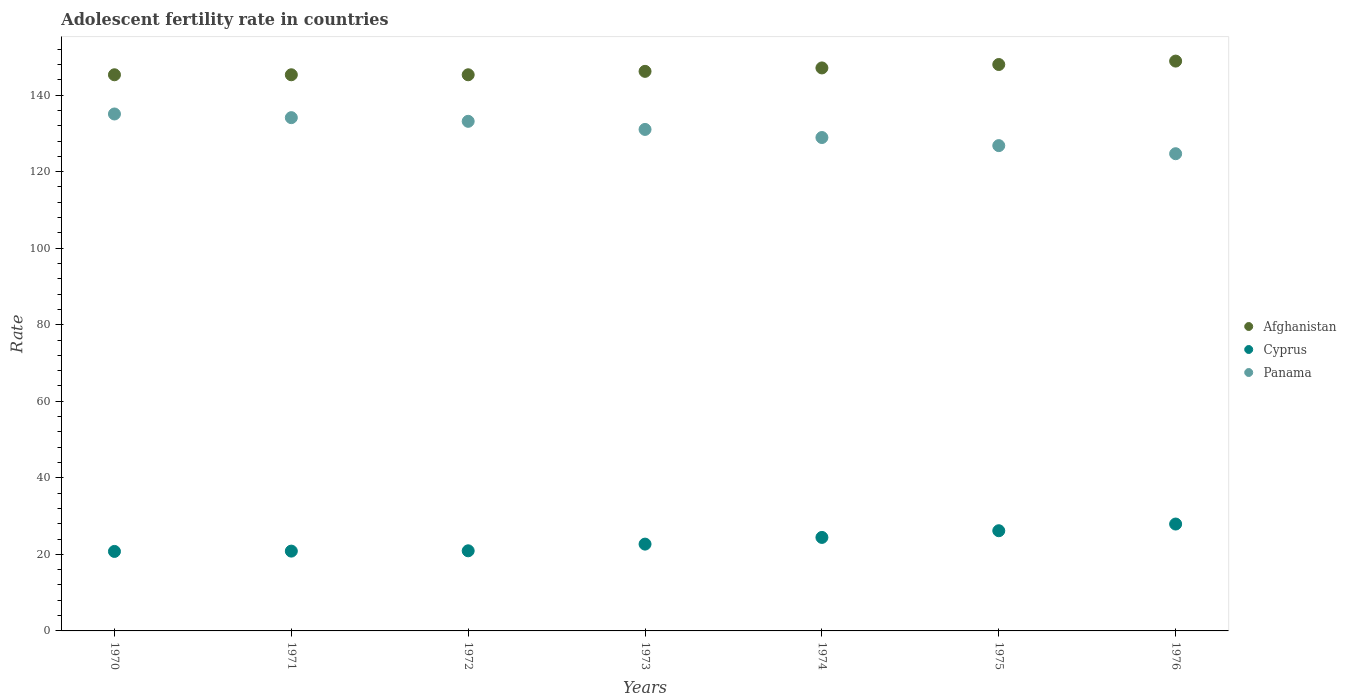How many different coloured dotlines are there?
Provide a succinct answer. 3. Is the number of dotlines equal to the number of legend labels?
Give a very brief answer. Yes. What is the adolescent fertility rate in Afghanistan in 1973?
Your response must be concise. 146.22. Across all years, what is the maximum adolescent fertility rate in Afghanistan?
Ensure brevity in your answer.  148.9. Across all years, what is the minimum adolescent fertility rate in Afghanistan?
Offer a very short reply. 145.32. In which year was the adolescent fertility rate in Panama maximum?
Offer a very short reply. 1970. What is the total adolescent fertility rate in Panama in the graph?
Your answer should be compact. 913.82. What is the difference between the adolescent fertility rate in Afghanistan in 1970 and that in 1975?
Ensure brevity in your answer.  -2.68. What is the difference between the adolescent fertility rate in Panama in 1975 and the adolescent fertility rate in Afghanistan in 1974?
Ensure brevity in your answer.  -20.3. What is the average adolescent fertility rate in Cyprus per year?
Give a very brief answer. 23.4. In the year 1972, what is the difference between the adolescent fertility rate in Cyprus and adolescent fertility rate in Afghanistan?
Offer a terse response. -124.38. What is the ratio of the adolescent fertility rate in Cyprus in 1972 to that in 1976?
Offer a very short reply. 0.75. Is the adolescent fertility rate in Panama in 1974 less than that in 1976?
Provide a short and direct response. No. Is the difference between the adolescent fertility rate in Cyprus in 1970 and 1974 greater than the difference between the adolescent fertility rate in Afghanistan in 1970 and 1974?
Your answer should be very brief. No. What is the difference between the highest and the second highest adolescent fertility rate in Panama?
Give a very brief answer. 0.96. What is the difference between the highest and the lowest adolescent fertility rate in Afghanistan?
Offer a terse response. 3.58. Is the adolescent fertility rate in Panama strictly greater than the adolescent fertility rate in Afghanistan over the years?
Your answer should be very brief. No. Is the adolescent fertility rate in Cyprus strictly less than the adolescent fertility rate in Afghanistan over the years?
Your answer should be very brief. Yes. How many years are there in the graph?
Provide a short and direct response. 7. What is the difference between two consecutive major ticks on the Y-axis?
Ensure brevity in your answer.  20. Does the graph contain any zero values?
Provide a short and direct response. No. Does the graph contain grids?
Provide a succinct answer. No. Where does the legend appear in the graph?
Offer a terse response. Center right. How many legend labels are there?
Give a very brief answer. 3. What is the title of the graph?
Offer a very short reply. Adolescent fertility rate in countries. Does "Botswana" appear as one of the legend labels in the graph?
Ensure brevity in your answer.  No. What is the label or title of the Y-axis?
Your answer should be very brief. Rate. What is the Rate in Afghanistan in 1970?
Give a very brief answer. 145.32. What is the Rate of Cyprus in 1970?
Keep it short and to the point. 20.77. What is the Rate in Panama in 1970?
Give a very brief answer. 135.08. What is the Rate of Afghanistan in 1971?
Offer a terse response. 145.32. What is the Rate in Cyprus in 1971?
Your answer should be compact. 20.85. What is the Rate in Panama in 1971?
Offer a very short reply. 134.12. What is the Rate of Afghanistan in 1972?
Ensure brevity in your answer.  145.32. What is the Rate in Cyprus in 1972?
Provide a short and direct response. 20.94. What is the Rate in Panama in 1972?
Provide a short and direct response. 133.16. What is the Rate in Afghanistan in 1973?
Your answer should be compact. 146.22. What is the Rate in Cyprus in 1973?
Offer a very short reply. 22.68. What is the Rate in Panama in 1973?
Ensure brevity in your answer.  131.04. What is the Rate in Afghanistan in 1974?
Give a very brief answer. 147.11. What is the Rate in Cyprus in 1974?
Ensure brevity in your answer.  24.43. What is the Rate in Panama in 1974?
Give a very brief answer. 128.93. What is the Rate in Afghanistan in 1975?
Your answer should be very brief. 148. What is the Rate of Cyprus in 1975?
Give a very brief answer. 26.18. What is the Rate in Panama in 1975?
Ensure brevity in your answer.  126.81. What is the Rate of Afghanistan in 1976?
Offer a terse response. 148.9. What is the Rate in Cyprus in 1976?
Make the answer very short. 27.93. What is the Rate of Panama in 1976?
Keep it short and to the point. 124.69. Across all years, what is the maximum Rate in Afghanistan?
Your answer should be compact. 148.9. Across all years, what is the maximum Rate in Cyprus?
Provide a short and direct response. 27.93. Across all years, what is the maximum Rate in Panama?
Your answer should be compact. 135.08. Across all years, what is the minimum Rate in Afghanistan?
Ensure brevity in your answer.  145.32. Across all years, what is the minimum Rate of Cyprus?
Your answer should be compact. 20.77. Across all years, what is the minimum Rate in Panama?
Make the answer very short. 124.69. What is the total Rate in Afghanistan in the graph?
Offer a very short reply. 1026.19. What is the total Rate in Cyprus in the graph?
Offer a very short reply. 163.79. What is the total Rate of Panama in the graph?
Give a very brief answer. 913.82. What is the difference between the Rate in Cyprus in 1970 and that in 1971?
Provide a succinct answer. -0.08. What is the difference between the Rate in Panama in 1970 and that in 1971?
Provide a short and direct response. 0.96. What is the difference between the Rate in Afghanistan in 1970 and that in 1972?
Your answer should be compact. 0. What is the difference between the Rate of Cyprus in 1970 and that in 1972?
Provide a succinct answer. -0.16. What is the difference between the Rate in Panama in 1970 and that in 1972?
Give a very brief answer. 1.92. What is the difference between the Rate of Afghanistan in 1970 and that in 1973?
Keep it short and to the point. -0.89. What is the difference between the Rate of Cyprus in 1970 and that in 1973?
Offer a very short reply. -1.91. What is the difference between the Rate in Panama in 1970 and that in 1973?
Your answer should be compact. 4.03. What is the difference between the Rate of Afghanistan in 1970 and that in 1974?
Your answer should be compact. -1.79. What is the difference between the Rate in Cyprus in 1970 and that in 1974?
Ensure brevity in your answer.  -3.66. What is the difference between the Rate of Panama in 1970 and that in 1974?
Ensure brevity in your answer.  6.15. What is the difference between the Rate of Afghanistan in 1970 and that in 1975?
Provide a succinct answer. -2.68. What is the difference between the Rate of Cyprus in 1970 and that in 1975?
Ensure brevity in your answer.  -5.41. What is the difference between the Rate of Panama in 1970 and that in 1975?
Provide a short and direct response. 8.27. What is the difference between the Rate in Afghanistan in 1970 and that in 1976?
Make the answer very short. -3.58. What is the difference between the Rate in Cyprus in 1970 and that in 1976?
Your answer should be very brief. -7.16. What is the difference between the Rate in Panama in 1970 and that in 1976?
Offer a terse response. 10.38. What is the difference between the Rate in Cyprus in 1971 and that in 1972?
Offer a terse response. -0.08. What is the difference between the Rate in Panama in 1971 and that in 1972?
Your response must be concise. 0.96. What is the difference between the Rate of Afghanistan in 1971 and that in 1973?
Keep it short and to the point. -0.89. What is the difference between the Rate of Cyprus in 1971 and that in 1973?
Offer a very short reply. -1.83. What is the difference between the Rate in Panama in 1971 and that in 1973?
Your answer should be compact. 3.08. What is the difference between the Rate of Afghanistan in 1971 and that in 1974?
Offer a very short reply. -1.79. What is the difference between the Rate in Cyprus in 1971 and that in 1974?
Make the answer very short. -3.58. What is the difference between the Rate of Panama in 1971 and that in 1974?
Provide a short and direct response. 5.19. What is the difference between the Rate in Afghanistan in 1971 and that in 1975?
Offer a very short reply. -2.68. What is the difference between the Rate of Cyprus in 1971 and that in 1975?
Ensure brevity in your answer.  -5.33. What is the difference between the Rate in Panama in 1971 and that in 1975?
Your answer should be compact. 7.31. What is the difference between the Rate of Afghanistan in 1971 and that in 1976?
Keep it short and to the point. -3.58. What is the difference between the Rate of Cyprus in 1971 and that in 1976?
Your answer should be compact. -7.07. What is the difference between the Rate in Panama in 1971 and that in 1976?
Your answer should be very brief. 9.42. What is the difference between the Rate of Afghanistan in 1972 and that in 1973?
Give a very brief answer. -0.89. What is the difference between the Rate in Cyprus in 1972 and that in 1973?
Offer a terse response. -1.75. What is the difference between the Rate in Panama in 1972 and that in 1973?
Make the answer very short. 2.12. What is the difference between the Rate in Afghanistan in 1972 and that in 1974?
Your answer should be very brief. -1.79. What is the difference between the Rate of Cyprus in 1972 and that in 1974?
Offer a very short reply. -3.5. What is the difference between the Rate of Panama in 1972 and that in 1974?
Give a very brief answer. 4.23. What is the difference between the Rate of Afghanistan in 1972 and that in 1975?
Provide a short and direct response. -2.68. What is the difference between the Rate in Cyprus in 1972 and that in 1975?
Provide a short and direct response. -5.24. What is the difference between the Rate of Panama in 1972 and that in 1975?
Your answer should be very brief. 6.35. What is the difference between the Rate in Afghanistan in 1972 and that in 1976?
Give a very brief answer. -3.58. What is the difference between the Rate of Cyprus in 1972 and that in 1976?
Your response must be concise. -6.99. What is the difference between the Rate in Panama in 1972 and that in 1976?
Ensure brevity in your answer.  8.46. What is the difference between the Rate of Afghanistan in 1973 and that in 1974?
Your answer should be compact. -0.89. What is the difference between the Rate in Cyprus in 1973 and that in 1974?
Your response must be concise. -1.75. What is the difference between the Rate of Panama in 1973 and that in 1974?
Your answer should be compact. 2.12. What is the difference between the Rate in Afghanistan in 1973 and that in 1975?
Give a very brief answer. -1.79. What is the difference between the Rate of Cyprus in 1973 and that in 1975?
Provide a short and direct response. -3.5. What is the difference between the Rate of Panama in 1973 and that in 1975?
Make the answer very short. 4.23. What is the difference between the Rate in Afghanistan in 1973 and that in 1976?
Give a very brief answer. -2.68. What is the difference between the Rate in Cyprus in 1973 and that in 1976?
Offer a very short reply. -5.24. What is the difference between the Rate in Panama in 1973 and that in 1976?
Provide a succinct answer. 6.35. What is the difference between the Rate in Afghanistan in 1974 and that in 1975?
Offer a very short reply. -0.89. What is the difference between the Rate in Cyprus in 1974 and that in 1975?
Your answer should be very brief. -1.75. What is the difference between the Rate in Panama in 1974 and that in 1975?
Provide a succinct answer. 2.12. What is the difference between the Rate in Afghanistan in 1974 and that in 1976?
Ensure brevity in your answer.  -1.79. What is the difference between the Rate of Cyprus in 1974 and that in 1976?
Your response must be concise. -3.5. What is the difference between the Rate in Panama in 1974 and that in 1976?
Make the answer very short. 4.23. What is the difference between the Rate in Afghanistan in 1975 and that in 1976?
Offer a very short reply. -0.89. What is the difference between the Rate of Cyprus in 1975 and that in 1976?
Ensure brevity in your answer.  -1.75. What is the difference between the Rate of Panama in 1975 and that in 1976?
Keep it short and to the point. 2.12. What is the difference between the Rate in Afghanistan in 1970 and the Rate in Cyprus in 1971?
Provide a succinct answer. 124.47. What is the difference between the Rate of Afghanistan in 1970 and the Rate of Panama in 1971?
Ensure brevity in your answer.  11.2. What is the difference between the Rate of Cyprus in 1970 and the Rate of Panama in 1971?
Offer a terse response. -113.35. What is the difference between the Rate of Afghanistan in 1970 and the Rate of Cyprus in 1972?
Keep it short and to the point. 124.39. What is the difference between the Rate in Afghanistan in 1970 and the Rate in Panama in 1972?
Keep it short and to the point. 12.16. What is the difference between the Rate of Cyprus in 1970 and the Rate of Panama in 1972?
Your answer should be very brief. -112.39. What is the difference between the Rate of Afghanistan in 1970 and the Rate of Cyprus in 1973?
Your answer should be compact. 122.64. What is the difference between the Rate of Afghanistan in 1970 and the Rate of Panama in 1973?
Offer a terse response. 14.28. What is the difference between the Rate of Cyprus in 1970 and the Rate of Panama in 1973?
Offer a very short reply. -110.27. What is the difference between the Rate in Afghanistan in 1970 and the Rate in Cyprus in 1974?
Provide a short and direct response. 120.89. What is the difference between the Rate of Afghanistan in 1970 and the Rate of Panama in 1974?
Provide a succinct answer. 16.4. What is the difference between the Rate in Cyprus in 1970 and the Rate in Panama in 1974?
Make the answer very short. -108.15. What is the difference between the Rate in Afghanistan in 1970 and the Rate in Cyprus in 1975?
Make the answer very short. 119.14. What is the difference between the Rate in Afghanistan in 1970 and the Rate in Panama in 1975?
Ensure brevity in your answer.  18.51. What is the difference between the Rate of Cyprus in 1970 and the Rate of Panama in 1975?
Give a very brief answer. -106.04. What is the difference between the Rate in Afghanistan in 1970 and the Rate in Cyprus in 1976?
Provide a short and direct response. 117.39. What is the difference between the Rate in Afghanistan in 1970 and the Rate in Panama in 1976?
Keep it short and to the point. 20.63. What is the difference between the Rate in Cyprus in 1970 and the Rate in Panama in 1976?
Your response must be concise. -103.92. What is the difference between the Rate of Afghanistan in 1971 and the Rate of Cyprus in 1972?
Your response must be concise. 124.39. What is the difference between the Rate in Afghanistan in 1971 and the Rate in Panama in 1972?
Keep it short and to the point. 12.16. What is the difference between the Rate of Cyprus in 1971 and the Rate of Panama in 1972?
Ensure brevity in your answer.  -112.3. What is the difference between the Rate of Afghanistan in 1971 and the Rate of Cyprus in 1973?
Your answer should be very brief. 122.64. What is the difference between the Rate in Afghanistan in 1971 and the Rate in Panama in 1973?
Offer a very short reply. 14.28. What is the difference between the Rate in Cyprus in 1971 and the Rate in Panama in 1973?
Give a very brief answer. -110.19. What is the difference between the Rate of Afghanistan in 1971 and the Rate of Cyprus in 1974?
Your answer should be very brief. 120.89. What is the difference between the Rate of Afghanistan in 1971 and the Rate of Panama in 1974?
Provide a succinct answer. 16.4. What is the difference between the Rate of Cyprus in 1971 and the Rate of Panama in 1974?
Give a very brief answer. -108.07. What is the difference between the Rate of Afghanistan in 1971 and the Rate of Cyprus in 1975?
Provide a short and direct response. 119.14. What is the difference between the Rate in Afghanistan in 1971 and the Rate in Panama in 1975?
Your response must be concise. 18.51. What is the difference between the Rate of Cyprus in 1971 and the Rate of Panama in 1975?
Your answer should be compact. -105.96. What is the difference between the Rate of Afghanistan in 1971 and the Rate of Cyprus in 1976?
Provide a succinct answer. 117.39. What is the difference between the Rate in Afghanistan in 1971 and the Rate in Panama in 1976?
Your answer should be compact. 20.63. What is the difference between the Rate in Cyprus in 1971 and the Rate in Panama in 1976?
Offer a very short reply. -103.84. What is the difference between the Rate in Afghanistan in 1972 and the Rate in Cyprus in 1973?
Make the answer very short. 122.64. What is the difference between the Rate in Afghanistan in 1972 and the Rate in Panama in 1973?
Make the answer very short. 14.28. What is the difference between the Rate in Cyprus in 1972 and the Rate in Panama in 1973?
Your answer should be compact. -110.11. What is the difference between the Rate in Afghanistan in 1972 and the Rate in Cyprus in 1974?
Offer a terse response. 120.89. What is the difference between the Rate in Afghanistan in 1972 and the Rate in Panama in 1974?
Offer a very short reply. 16.4. What is the difference between the Rate in Cyprus in 1972 and the Rate in Panama in 1974?
Offer a very short reply. -107.99. What is the difference between the Rate of Afghanistan in 1972 and the Rate of Cyprus in 1975?
Provide a succinct answer. 119.14. What is the difference between the Rate in Afghanistan in 1972 and the Rate in Panama in 1975?
Your answer should be compact. 18.51. What is the difference between the Rate in Cyprus in 1972 and the Rate in Panama in 1975?
Provide a succinct answer. -105.87. What is the difference between the Rate in Afghanistan in 1972 and the Rate in Cyprus in 1976?
Your answer should be very brief. 117.39. What is the difference between the Rate of Afghanistan in 1972 and the Rate of Panama in 1976?
Your response must be concise. 20.63. What is the difference between the Rate of Cyprus in 1972 and the Rate of Panama in 1976?
Keep it short and to the point. -103.76. What is the difference between the Rate in Afghanistan in 1973 and the Rate in Cyprus in 1974?
Your response must be concise. 121.78. What is the difference between the Rate of Afghanistan in 1973 and the Rate of Panama in 1974?
Ensure brevity in your answer.  17.29. What is the difference between the Rate in Cyprus in 1973 and the Rate in Panama in 1974?
Make the answer very short. -106.24. What is the difference between the Rate in Afghanistan in 1973 and the Rate in Cyprus in 1975?
Give a very brief answer. 120.03. What is the difference between the Rate of Afghanistan in 1973 and the Rate of Panama in 1975?
Offer a very short reply. 19.41. What is the difference between the Rate in Cyprus in 1973 and the Rate in Panama in 1975?
Give a very brief answer. -104.13. What is the difference between the Rate of Afghanistan in 1973 and the Rate of Cyprus in 1976?
Make the answer very short. 118.29. What is the difference between the Rate of Afghanistan in 1973 and the Rate of Panama in 1976?
Your response must be concise. 21.52. What is the difference between the Rate of Cyprus in 1973 and the Rate of Panama in 1976?
Provide a succinct answer. -102.01. What is the difference between the Rate in Afghanistan in 1974 and the Rate in Cyprus in 1975?
Provide a short and direct response. 120.93. What is the difference between the Rate of Afghanistan in 1974 and the Rate of Panama in 1975?
Offer a terse response. 20.3. What is the difference between the Rate in Cyprus in 1974 and the Rate in Panama in 1975?
Your response must be concise. -102.38. What is the difference between the Rate of Afghanistan in 1974 and the Rate of Cyprus in 1976?
Your response must be concise. 119.18. What is the difference between the Rate of Afghanistan in 1974 and the Rate of Panama in 1976?
Ensure brevity in your answer.  22.42. What is the difference between the Rate in Cyprus in 1974 and the Rate in Panama in 1976?
Offer a terse response. -100.26. What is the difference between the Rate of Afghanistan in 1975 and the Rate of Cyprus in 1976?
Your response must be concise. 120.08. What is the difference between the Rate of Afghanistan in 1975 and the Rate of Panama in 1976?
Keep it short and to the point. 23.31. What is the difference between the Rate of Cyprus in 1975 and the Rate of Panama in 1976?
Your answer should be very brief. -98.51. What is the average Rate in Afghanistan per year?
Make the answer very short. 146.6. What is the average Rate of Cyprus per year?
Make the answer very short. 23.4. What is the average Rate of Panama per year?
Your answer should be very brief. 130.55. In the year 1970, what is the difference between the Rate in Afghanistan and Rate in Cyprus?
Offer a terse response. 124.55. In the year 1970, what is the difference between the Rate in Afghanistan and Rate in Panama?
Your answer should be very brief. 10.24. In the year 1970, what is the difference between the Rate of Cyprus and Rate of Panama?
Your answer should be compact. -114.3. In the year 1971, what is the difference between the Rate of Afghanistan and Rate of Cyprus?
Ensure brevity in your answer.  124.47. In the year 1971, what is the difference between the Rate in Afghanistan and Rate in Panama?
Your response must be concise. 11.2. In the year 1971, what is the difference between the Rate of Cyprus and Rate of Panama?
Keep it short and to the point. -113.26. In the year 1972, what is the difference between the Rate of Afghanistan and Rate of Cyprus?
Ensure brevity in your answer.  124.39. In the year 1972, what is the difference between the Rate in Afghanistan and Rate in Panama?
Ensure brevity in your answer.  12.16. In the year 1972, what is the difference between the Rate in Cyprus and Rate in Panama?
Make the answer very short. -112.22. In the year 1973, what is the difference between the Rate of Afghanistan and Rate of Cyprus?
Give a very brief answer. 123.53. In the year 1973, what is the difference between the Rate of Afghanistan and Rate of Panama?
Ensure brevity in your answer.  15.17. In the year 1973, what is the difference between the Rate of Cyprus and Rate of Panama?
Offer a very short reply. -108.36. In the year 1974, what is the difference between the Rate in Afghanistan and Rate in Cyprus?
Make the answer very short. 122.68. In the year 1974, what is the difference between the Rate in Afghanistan and Rate in Panama?
Give a very brief answer. 18.18. In the year 1974, what is the difference between the Rate of Cyprus and Rate of Panama?
Your answer should be very brief. -104.49. In the year 1975, what is the difference between the Rate in Afghanistan and Rate in Cyprus?
Your answer should be very brief. 121.82. In the year 1975, what is the difference between the Rate of Afghanistan and Rate of Panama?
Ensure brevity in your answer.  21.19. In the year 1975, what is the difference between the Rate in Cyprus and Rate in Panama?
Offer a very short reply. -100.63. In the year 1976, what is the difference between the Rate of Afghanistan and Rate of Cyprus?
Offer a terse response. 120.97. In the year 1976, what is the difference between the Rate in Afghanistan and Rate in Panama?
Your answer should be compact. 24.2. In the year 1976, what is the difference between the Rate of Cyprus and Rate of Panama?
Provide a short and direct response. -96.77. What is the ratio of the Rate in Afghanistan in 1970 to that in 1971?
Make the answer very short. 1. What is the ratio of the Rate in Panama in 1970 to that in 1971?
Provide a short and direct response. 1.01. What is the ratio of the Rate of Cyprus in 1970 to that in 1972?
Keep it short and to the point. 0.99. What is the ratio of the Rate of Panama in 1970 to that in 1972?
Give a very brief answer. 1.01. What is the ratio of the Rate of Cyprus in 1970 to that in 1973?
Your answer should be very brief. 0.92. What is the ratio of the Rate in Panama in 1970 to that in 1973?
Provide a succinct answer. 1.03. What is the ratio of the Rate of Cyprus in 1970 to that in 1974?
Make the answer very short. 0.85. What is the ratio of the Rate in Panama in 1970 to that in 1974?
Offer a very short reply. 1.05. What is the ratio of the Rate of Afghanistan in 1970 to that in 1975?
Make the answer very short. 0.98. What is the ratio of the Rate in Cyprus in 1970 to that in 1975?
Make the answer very short. 0.79. What is the ratio of the Rate in Panama in 1970 to that in 1975?
Offer a very short reply. 1.07. What is the ratio of the Rate in Afghanistan in 1970 to that in 1976?
Give a very brief answer. 0.98. What is the ratio of the Rate in Cyprus in 1970 to that in 1976?
Provide a short and direct response. 0.74. What is the ratio of the Rate of Afghanistan in 1971 to that in 1972?
Your response must be concise. 1. What is the ratio of the Rate in Panama in 1971 to that in 1972?
Offer a terse response. 1.01. What is the ratio of the Rate in Cyprus in 1971 to that in 1973?
Ensure brevity in your answer.  0.92. What is the ratio of the Rate in Panama in 1971 to that in 1973?
Your answer should be very brief. 1.02. What is the ratio of the Rate of Cyprus in 1971 to that in 1974?
Keep it short and to the point. 0.85. What is the ratio of the Rate in Panama in 1971 to that in 1974?
Ensure brevity in your answer.  1.04. What is the ratio of the Rate in Afghanistan in 1971 to that in 1975?
Provide a short and direct response. 0.98. What is the ratio of the Rate of Cyprus in 1971 to that in 1975?
Provide a short and direct response. 0.8. What is the ratio of the Rate of Panama in 1971 to that in 1975?
Ensure brevity in your answer.  1.06. What is the ratio of the Rate in Cyprus in 1971 to that in 1976?
Keep it short and to the point. 0.75. What is the ratio of the Rate in Panama in 1971 to that in 1976?
Offer a very short reply. 1.08. What is the ratio of the Rate of Afghanistan in 1972 to that in 1973?
Keep it short and to the point. 0.99. What is the ratio of the Rate of Cyprus in 1972 to that in 1973?
Make the answer very short. 0.92. What is the ratio of the Rate in Panama in 1972 to that in 1973?
Your response must be concise. 1.02. What is the ratio of the Rate in Cyprus in 1972 to that in 1974?
Your answer should be very brief. 0.86. What is the ratio of the Rate of Panama in 1972 to that in 1974?
Make the answer very short. 1.03. What is the ratio of the Rate of Afghanistan in 1972 to that in 1975?
Your answer should be very brief. 0.98. What is the ratio of the Rate of Cyprus in 1972 to that in 1975?
Give a very brief answer. 0.8. What is the ratio of the Rate of Panama in 1972 to that in 1975?
Provide a succinct answer. 1.05. What is the ratio of the Rate in Afghanistan in 1972 to that in 1976?
Give a very brief answer. 0.98. What is the ratio of the Rate of Cyprus in 1972 to that in 1976?
Provide a succinct answer. 0.75. What is the ratio of the Rate of Panama in 1972 to that in 1976?
Offer a very short reply. 1.07. What is the ratio of the Rate of Afghanistan in 1973 to that in 1974?
Provide a short and direct response. 0.99. What is the ratio of the Rate of Cyprus in 1973 to that in 1974?
Give a very brief answer. 0.93. What is the ratio of the Rate in Panama in 1973 to that in 1974?
Offer a very short reply. 1.02. What is the ratio of the Rate in Afghanistan in 1973 to that in 1975?
Make the answer very short. 0.99. What is the ratio of the Rate of Cyprus in 1973 to that in 1975?
Offer a very short reply. 0.87. What is the ratio of the Rate of Panama in 1973 to that in 1975?
Keep it short and to the point. 1.03. What is the ratio of the Rate in Cyprus in 1973 to that in 1976?
Give a very brief answer. 0.81. What is the ratio of the Rate in Panama in 1973 to that in 1976?
Offer a very short reply. 1.05. What is the ratio of the Rate of Afghanistan in 1974 to that in 1975?
Offer a terse response. 0.99. What is the ratio of the Rate in Cyprus in 1974 to that in 1975?
Offer a very short reply. 0.93. What is the ratio of the Rate in Panama in 1974 to that in 1975?
Provide a short and direct response. 1.02. What is the ratio of the Rate in Afghanistan in 1974 to that in 1976?
Make the answer very short. 0.99. What is the ratio of the Rate in Cyprus in 1974 to that in 1976?
Your answer should be compact. 0.87. What is the ratio of the Rate in Panama in 1974 to that in 1976?
Your answer should be compact. 1.03. What is the ratio of the Rate in Cyprus in 1975 to that in 1976?
Offer a terse response. 0.94. What is the difference between the highest and the second highest Rate of Afghanistan?
Ensure brevity in your answer.  0.89. What is the difference between the highest and the second highest Rate of Cyprus?
Your answer should be compact. 1.75. What is the difference between the highest and the second highest Rate of Panama?
Offer a very short reply. 0.96. What is the difference between the highest and the lowest Rate of Afghanistan?
Offer a terse response. 3.58. What is the difference between the highest and the lowest Rate of Cyprus?
Provide a succinct answer. 7.16. What is the difference between the highest and the lowest Rate of Panama?
Make the answer very short. 10.38. 